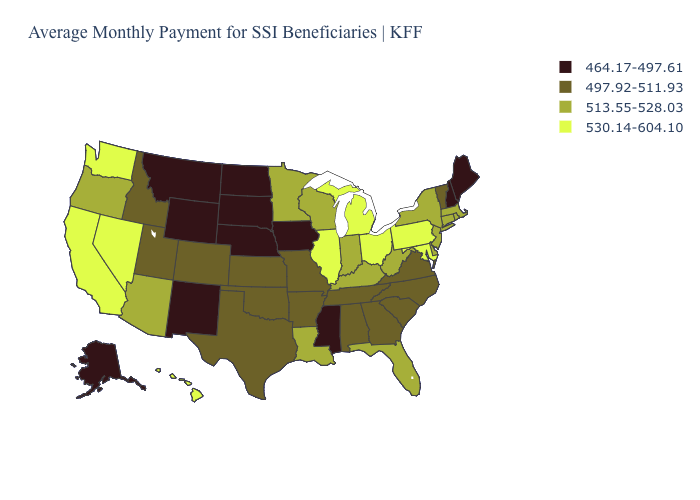Among the states that border Kentucky , which have the highest value?
Be succinct. Illinois, Ohio. What is the value of Wisconsin?
Answer briefly. 513.55-528.03. Among the states that border South Carolina , which have the lowest value?
Write a very short answer. Georgia, North Carolina. What is the lowest value in the MidWest?
Concise answer only. 464.17-497.61. Does the first symbol in the legend represent the smallest category?
Short answer required. Yes. Which states have the lowest value in the South?
Write a very short answer. Mississippi. Does the first symbol in the legend represent the smallest category?
Concise answer only. Yes. How many symbols are there in the legend?
Short answer required. 4. What is the value of New Hampshire?
Write a very short answer. 464.17-497.61. Which states have the lowest value in the Northeast?
Write a very short answer. Maine, New Hampshire. Among the states that border Pennsylvania , does New York have the highest value?
Be succinct. No. Name the states that have a value in the range 497.92-511.93?
Answer briefly. Alabama, Arkansas, Colorado, Georgia, Idaho, Kansas, Missouri, North Carolina, Oklahoma, South Carolina, Tennessee, Texas, Utah, Vermont, Virginia. What is the lowest value in states that border Iowa?
Write a very short answer. 464.17-497.61. What is the value of Wisconsin?
Be succinct. 513.55-528.03. 